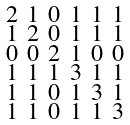Convert formula to latex. <formula><loc_0><loc_0><loc_500><loc_500>\begin{smallmatrix} 2 & 1 & 0 & 1 & 1 & 1 \\ 1 & 2 & 0 & 1 & 1 & 1 \\ 0 & 0 & 2 & 1 & 0 & 0 \\ 1 & 1 & 1 & 3 & 1 & 1 \\ 1 & 1 & 0 & 1 & 3 & 1 \\ 1 & 1 & 0 & 1 & 1 & 3 \end{smallmatrix}</formula> 